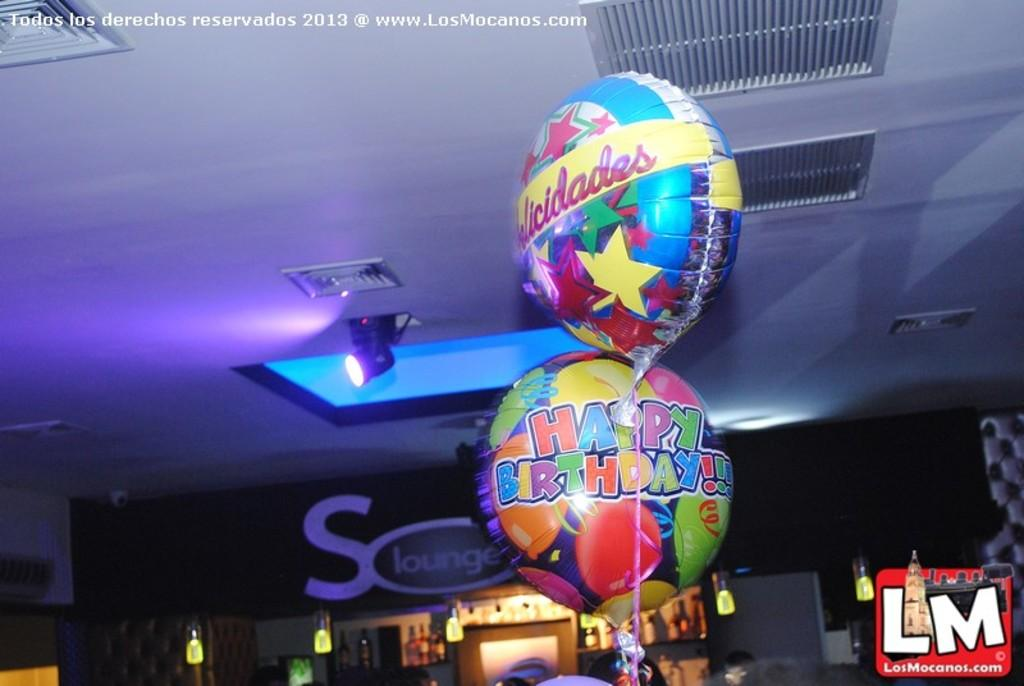Provide a one-sentence caption for the provided image. Two balloons one of which says Happy Birthday and they are multi colored and in a dark room with a light casting a purple glow. 